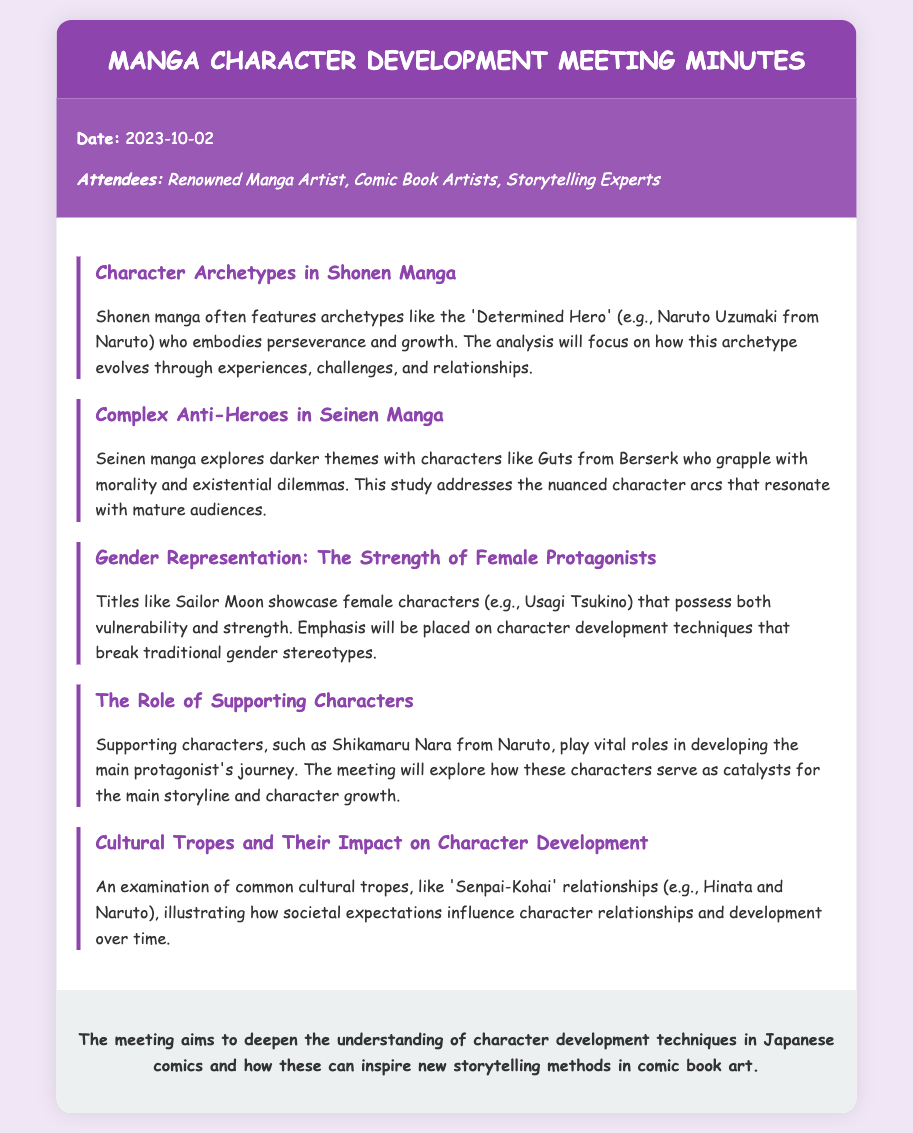What is the date of the meeting? The date is explicitly mentioned in the document.
Answer: 2023-10-02 Who is the protagonist of Naruto mentioned as an archetype? The document names a specific character from a popular shonen manga as an example.
Answer: Naruto Uzumaki Which character is highlighted in the analysis of Seinen manga? The document specifically mentions a character associated with darker themes in Seinen manga.
Answer: Guts What trope illustrates societal expectations in character relationships? A specific cultural trope is identified in the document.
Answer: Senpai-Kohai What is emphasized in the development of Usagi Tsukino in Sailor Moon? This refers to a characteristic of female protagonists discussed in the document.
Answer: Vulnerability and strength How many key points are discussed in the document? The number of key points is indicated by the list provided in the key-points section.
Answer: Five 